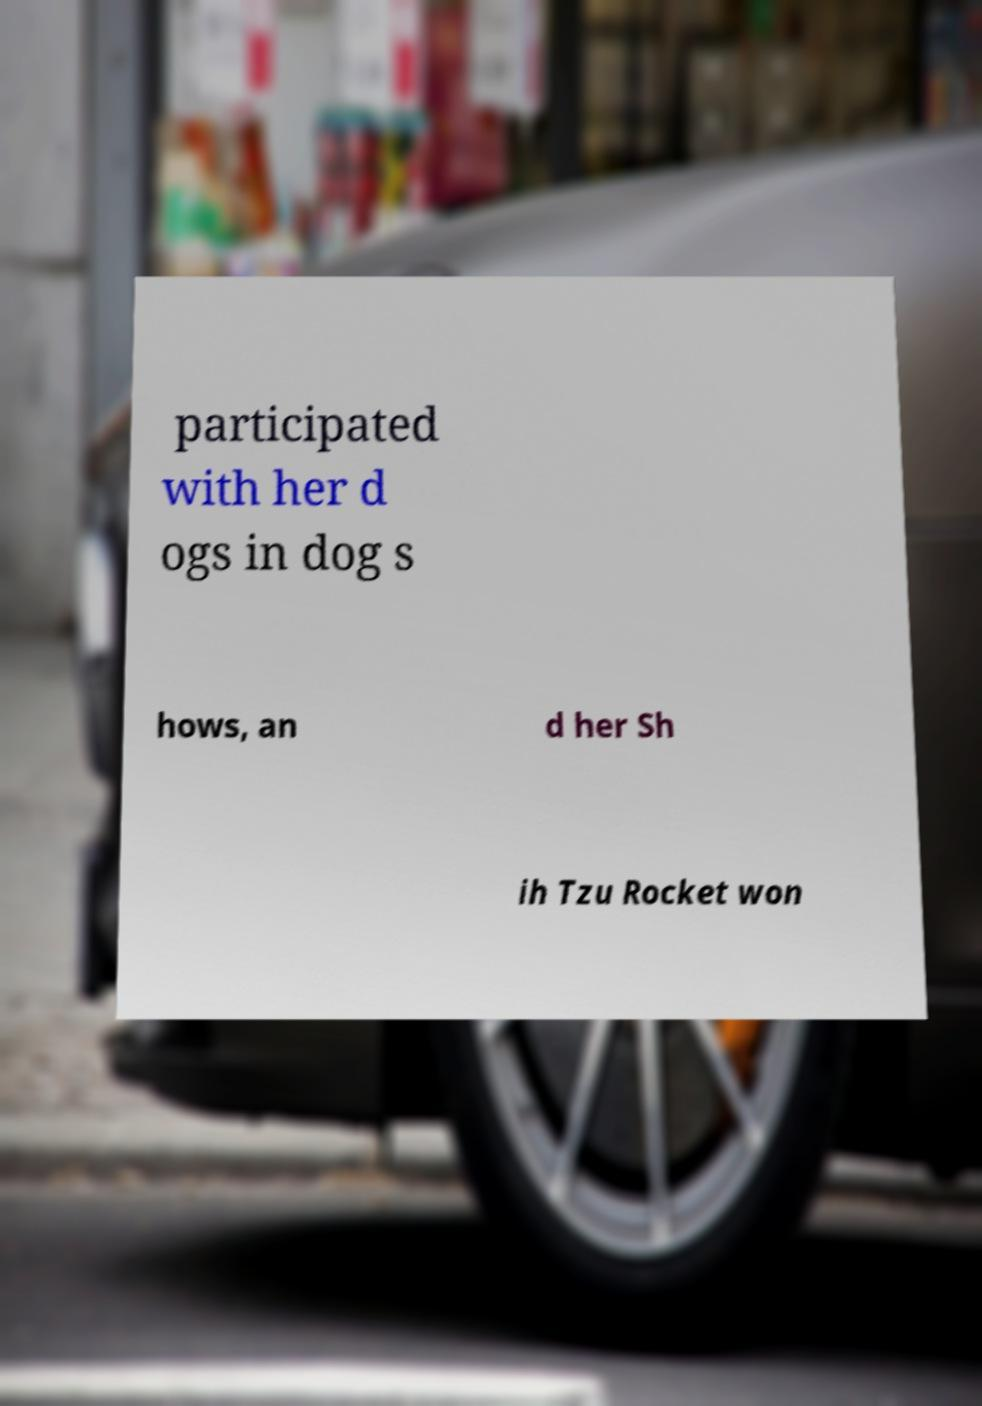Please identify and transcribe the text found in this image. participated with her d ogs in dog s hows, an d her Sh ih Tzu Rocket won 